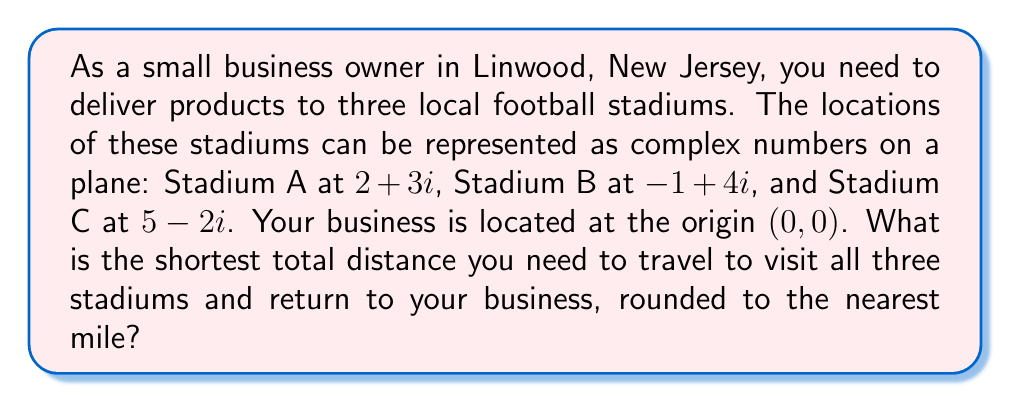Can you solve this math problem? Let's approach this step-by-step using complex plane geometry:

1) First, we need to calculate the distances between all points. We can do this using the distance formula for complex numbers:
   $d = |z_1 - z_2|$, where $z_1$ and $z_2$ are complex numbers.

2) Let's calculate all possible distances:
   - Business to A: $|0 - (2+3i)| = |(-2-3i)| = \sqrt{(-2)^2 + (-3)^2} = \sqrt{13}$
   - Business to B: $|0 - (-1+4i)| = |(1-4i)| = \sqrt{1^2 + (-4)^2} = \sqrt{17}$
   - Business to C: $|0 - (5-2i)| = |(-5+2i)| = \sqrt{(-5)^2 + 2^2} = \sqrt{29}$
   - A to B: $|(2+3i) - (-1+4i)| = |(3-i)| = \sqrt{3^2 + (-1)^2} = \sqrt{10}$
   - A to C: $|(2+3i) - (5-2i)| = |(-3+5i)| = \sqrt{(-3)^2 + 5^2} = \sqrt{34}$
   - B to C: $|(-1+4i) - (5-2i)| = |(-6+6i)| = \sqrt{(-6)^2 + 6^2} = 6\sqrt{2}$

3) To find the shortest route, we need to consider all possible paths:
   - Business -> A -> B -> C -> Business: $\sqrt{13} + \sqrt{10} + 6\sqrt{2} + \sqrt{29}$
   - Business -> A -> C -> B -> Business: $\sqrt{13} + \sqrt{34} + 6\sqrt{2} + \sqrt{17}$
   - Business -> B -> A -> C -> Business: $\sqrt{17} + \sqrt{10} + \sqrt{34} + \sqrt{29}$
   - Business -> B -> C -> A -> Business: $\sqrt{17} + 6\sqrt{2} + \sqrt{34} + \sqrt{13}$
   - Business -> C -> A -> B -> Business: $\sqrt{29} + \sqrt{34} + \sqrt{10} + \sqrt{17}$
   - Business -> C -> B -> A -> Business: $\sqrt{29} + 6\sqrt{2} + \sqrt{10} + \sqrt{13}$

4) Calculating these values:
   - Route 1: ≈ 21.60 miles
   - Route 2: ≈ 22.94 miles
   - Route 3: ≈ 22.72 miles
   - Route 4: ≈ 22.94 miles
   - Route 5: ≈ 22.72 miles
   - Route 6: ≈ 21.60 miles

5) The shortest routes are 1 and 6, both approximately 21.60 miles.
Answer: 22 miles 